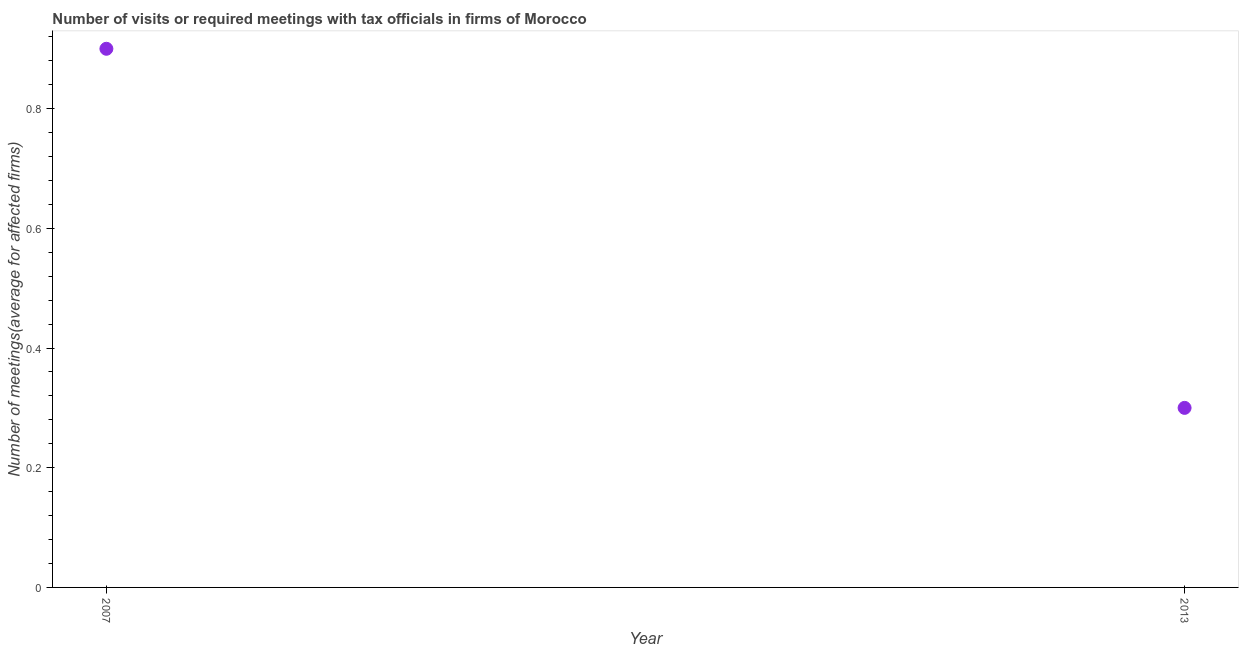What is the number of required meetings with tax officials in 2007?
Your answer should be very brief. 0.9. Across all years, what is the maximum number of required meetings with tax officials?
Offer a terse response. 0.9. In which year was the number of required meetings with tax officials minimum?
Provide a succinct answer. 2013. What is the difference between the number of required meetings with tax officials in 2007 and 2013?
Make the answer very short. 0.6. Do a majority of the years between 2013 and 2007 (inclusive) have number of required meetings with tax officials greater than 0.12 ?
Make the answer very short. No. What is the difference between two consecutive major ticks on the Y-axis?
Your answer should be compact. 0.2. What is the title of the graph?
Offer a very short reply. Number of visits or required meetings with tax officials in firms of Morocco. What is the label or title of the Y-axis?
Provide a short and direct response. Number of meetings(average for affected firms). What is the difference between the Number of meetings(average for affected firms) in 2007 and 2013?
Ensure brevity in your answer.  0.6. 